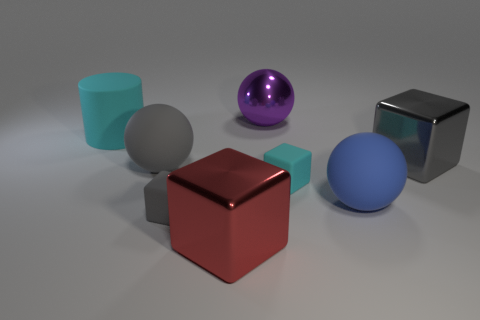Is the number of large purple metal things that are to the right of the large purple shiny sphere the same as the number of small brown matte blocks?
Offer a very short reply. Yes. Does the metallic thing to the right of the purple object have the same size as the cyan rubber thing that is right of the large gray matte thing?
Provide a succinct answer. No. How many other objects are the same size as the gray sphere?
Offer a very short reply. 5. There is a large metallic cube in front of the cyan object right of the big purple object; is there a big metal block that is to the right of it?
Provide a succinct answer. Yes. Is there anything else of the same color as the big cylinder?
Keep it short and to the point. Yes. What size is the cyan thing on the right side of the red metal block?
Provide a succinct answer. Small. There is a object on the left side of the big ball that is on the left side of the small gray block that is in front of the large gray rubber ball; what size is it?
Your answer should be compact. Large. The big matte object that is on the right side of the cyan matte thing that is on the right side of the cylinder is what color?
Offer a terse response. Blue. What is the material of the large purple thing that is the same shape as the large blue rubber object?
Ensure brevity in your answer.  Metal. Is there anything else that is made of the same material as the small gray thing?
Provide a succinct answer. Yes. 